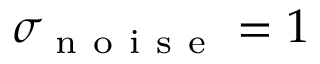<formula> <loc_0><loc_0><loc_500><loc_500>\sigma _ { n o i s e } = 1</formula> 